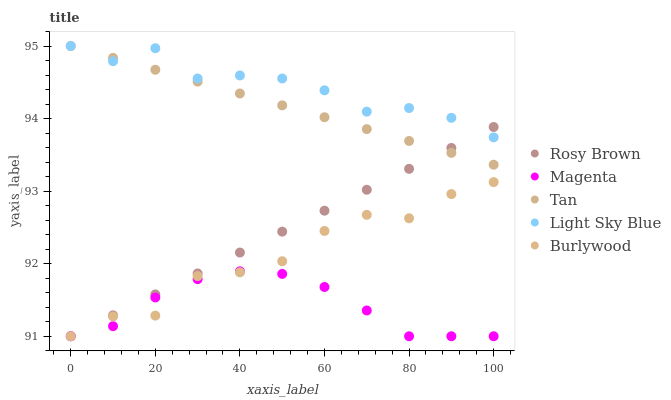Does Magenta have the minimum area under the curve?
Answer yes or no. Yes. Does Light Sky Blue have the maximum area under the curve?
Answer yes or no. Yes. Does Rosy Brown have the minimum area under the curve?
Answer yes or no. No. Does Rosy Brown have the maximum area under the curve?
Answer yes or no. No. Is Tan the smoothest?
Answer yes or no. Yes. Is Burlywood the roughest?
Answer yes or no. Yes. Is Magenta the smoothest?
Answer yes or no. No. Is Magenta the roughest?
Answer yes or no. No. Does Burlywood have the lowest value?
Answer yes or no. Yes. Does Tan have the lowest value?
Answer yes or no. No. Does Light Sky Blue have the highest value?
Answer yes or no. Yes. Does Rosy Brown have the highest value?
Answer yes or no. No. Is Burlywood less than Light Sky Blue?
Answer yes or no. Yes. Is Light Sky Blue greater than Magenta?
Answer yes or no. Yes. Does Burlywood intersect Rosy Brown?
Answer yes or no. Yes. Is Burlywood less than Rosy Brown?
Answer yes or no. No. Is Burlywood greater than Rosy Brown?
Answer yes or no. No. Does Burlywood intersect Light Sky Blue?
Answer yes or no. No. 